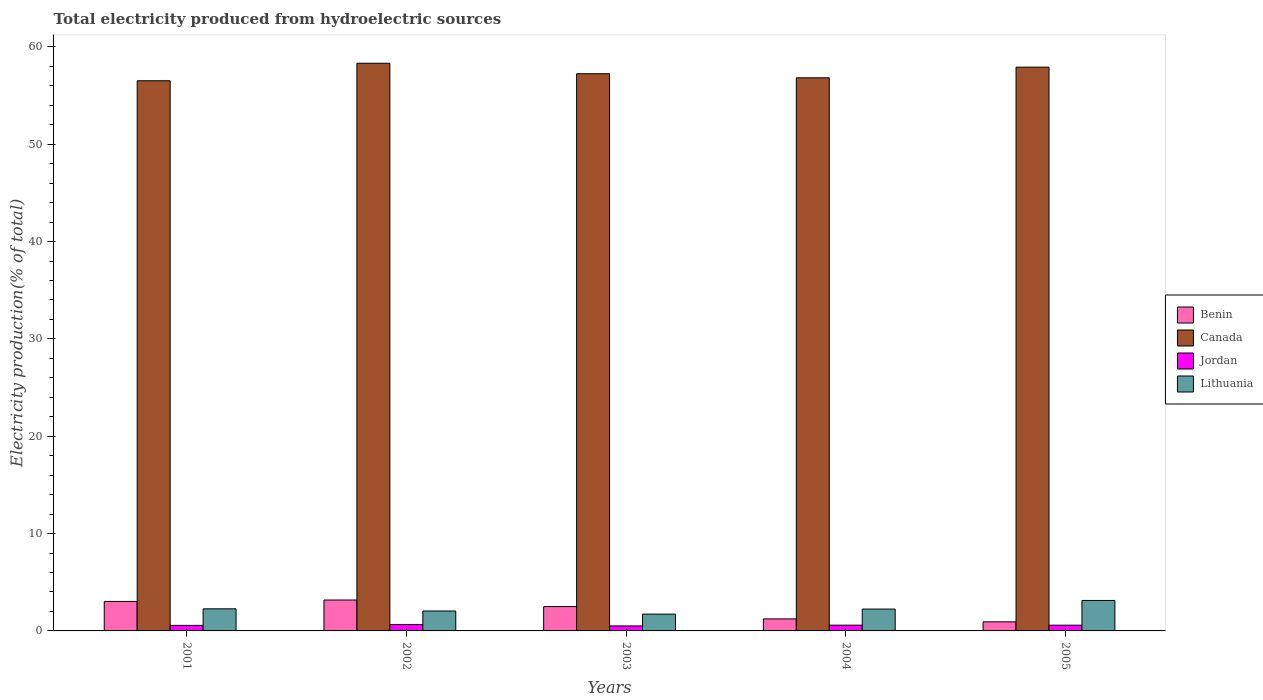How many different coloured bars are there?
Offer a terse response. 4. Are the number of bars per tick equal to the number of legend labels?
Offer a very short reply. Yes. Are the number of bars on each tick of the X-axis equal?
Offer a terse response. Yes. How many bars are there on the 4th tick from the left?
Give a very brief answer. 4. In how many cases, is the number of bars for a given year not equal to the number of legend labels?
Make the answer very short. 0. What is the total electricity produced in Benin in 2005?
Your response must be concise. 0.93. Across all years, what is the maximum total electricity produced in Lithuania?
Your answer should be compact. 3.13. Across all years, what is the minimum total electricity produced in Lithuania?
Offer a very short reply. 1.73. In which year was the total electricity produced in Lithuania maximum?
Offer a very short reply. 2005. What is the total total electricity produced in Jordan in the graph?
Your answer should be very brief. 2.92. What is the difference between the total electricity produced in Benin in 2001 and that in 2004?
Offer a very short reply. 1.8. What is the difference between the total electricity produced in Jordan in 2003 and the total electricity produced in Canada in 2001?
Offer a terse response. -56. What is the average total electricity produced in Jordan per year?
Your response must be concise. 0.58. In the year 2002, what is the difference between the total electricity produced in Benin and total electricity produced in Jordan?
Your response must be concise. 2.52. What is the ratio of the total electricity produced in Lithuania in 2002 to that in 2003?
Keep it short and to the point. 1.19. Is the difference between the total electricity produced in Benin in 2002 and 2005 greater than the difference between the total electricity produced in Jordan in 2002 and 2005?
Your response must be concise. Yes. What is the difference between the highest and the second highest total electricity produced in Canada?
Ensure brevity in your answer.  0.4. What is the difference between the highest and the lowest total electricity produced in Benin?
Your answer should be very brief. 2.24. In how many years, is the total electricity produced in Benin greater than the average total electricity produced in Benin taken over all years?
Your answer should be very brief. 3. Is it the case that in every year, the sum of the total electricity produced in Jordan and total electricity produced in Lithuania is greater than the sum of total electricity produced in Benin and total electricity produced in Canada?
Your answer should be compact. Yes. What does the 1st bar from the left in 2002 represents?
Your answer should be very brief. Benin. What does the 2nd bar from the right in 2004 represents?
Ensure brevity in your answer.  Jordan. Is it the case that in every year, the sum of the total electricity produced in Canada and total electricity produced in Jordan is greater than the total electricity produced in Benin?
Provide a succinct answer. Yes. How many bars are there?
Provide a short and direct response. 20. Are all the bars in the graph horizontal?
Provide a succinct answer. No. How many years are there in the graph?
Keep it short and to the point. 5. Are the values on the major ticks of Y-axis written in scientific E-notation?
Ensure brevity in your answer.  No. Where does the legend appear in the graph?
Provide a succinct answer. Center right. How many legend labels are there?
Your answer should be compact. 4. How are the legend labels stacked?
Offer a very short reply. Vertical. What is the title of the graph?
Ensure brevity in your answer.  Total electricity produced from hydroelectric sources. Does "Middle East & North Africa (developing only)" appear as one of the legend labels in the graph?
Your answer should be very brief. No. What is the Electricity production(% of total) in Benin in 2001?
Offer a very short reply. 3.03. What is the Electricity production(% of total) in Canada in 2001?
Provide a succinct answer. 56.52. What is the Electricity production(% of total) in Jordan in 2001?
Offer a terse response. 0.57. What is the Electricity production(% of total) of Lithuania in 2001?
Provide a short and direct response. 2.27. What is the Electricity production(% of total) in Benin in 2002?
Your response must be concise. 3.17. What is the Electricity production(% of total) in Canada in 2002?
Provide a short and direct response. 58.31. What is the Electricity production(% of total) in Jordan in 2002?
Keep it short and to the point. 0.65. What is the Electricity production(% of total) of Lithuania in 2002?
Give a very brief answer. 2.05. What is the Electricity production(% of total) of Benin in 2003?
Offer a very short reply. 2.5. What is the Electricity production(% of total) in Canada in 2003?
Keep it short and to the point. 57.24. What is the Electricity production(% of total) in Jordan in 2003?
Keep it short and to the point. 0.51. What is the Electricity production(% of total) of Lithuania in 2003?
Provide a short and direct response. 1.73. What is the Electricity production(% of total) of Benin in 2004?
Offer a very short reply. 1.23. What is the Electricity production(% of total) of Canada in 2004?
Your answer should be very brief. 56.82. What is the Electricity production(% of total) in Jordan in 2004?
Offer a terse response. 0.59. What is the Electricity production(% of total) in Lithuania in 2004?
Ensure brevity in your answer.  2.25. What is the Electricity production(% of total) in Benin in 2005?
Provide a short and direct response. 0.93. What is the Electricity production(% of total) of Canada in 2005?
Keep it short and to the point. 57.91. What is the Electricity production(% of total) in Jordan in 2005?
Provide a succinct answer. 0.59. What is the Electricity production(% of total) in Lithuania in 2005?
Provide a succinct answer. 3.13. Across all years, what is the maximum Electricity production(% of total) in Benin?
Provide a succinct answer. 3.17. Across all years, what is the maximum Electricity production(% of total) in Canada?
Your response must be concise. 58.31. Across all years, what is the maximum Electricity production(% of total) of Jordan?
Offer a terse response. 0.65. Across all years, what is the maximum Electricity production(% of total) of Lithuania?
Offer a very short reply. 3.13. Across all years, what is the minimum Electricity production(% of total) of Benin?
Make the answer very short. 0.93. Across all years, what is the minimum Electricity production(% of total) in Canada?
Give a very brief answer. 56.52. Across all years, what is the minimum Electricity production(% of total) in Jordan?
Ensure brevity in your answer.  0.51. Across all years, what is the minimum Electricity production(% of total) of Lithuania?
Your answer should be very brief. 1.73. What is the total Electricity production(% of total) in Benin in the graph?
Your response must be concise. 10.87. What is the total Electricity production(% of total) in Canada in the graph?
Provide a succinct answer. 286.8. What is the total Electricity production(% of total) of Jordan in the graph?
Your answer should be very brief. 2.92. What is the total Electricity production(% of total) of Lithuania in the graph?
Provide a succinct answer. 11.42. What is the difference between the Electricity production(% of total) of Benin in 2001 and that in 2002?
Keep it short and to the point. -0.14. What is the difference between the Electricity production(% of total) of Canada in 2001 and that in 2002?
Provide a succinct answer. -1.8. What is the difference between the Electricity production(% of total) of Jordan in 2001 and that in 2002?
Offer a terse response. -0.08. What is the difference between the Electricity production(% of total) in Lithuania in 2001 and that in 2002?
Make the answer very short. 0.22. What is the difference between the Electricity production(% of total) in Benin in 2001 and that in 2003?
Your response must be concise. 0.53. What is the difference between the Electricity production(% of total) of Canada in 2001 and that in 2003?
Your answer should be compact. -0.72. What is the difference between the Electricity production(% of total) of Jordan in 2001 and that in 2003?
Your response must be concise. 0.06. What is the difference between the Electricity production(% of total) in Lithuania in 2001 and that in 2003?
Your answer should be very brief. 0.54. What is the difference between the Electricity production(% of total) in Benin in 2001 and that in 2004?
Provide a succinct answer. 1.8. What is the difference between the Electricity production(% of total) in Canada in 2001 and that in 2004?
Ensure brevity in your answer.  -0.3. What is the difference between the Electricity production(% of total) in Jordan in 2001 and that in 2004?
Provide a succinct answer. -0.02. What is the difference between the Electricity production(% of total) in Lithuania in 2001 and that in 2004?
Ensure brevity in your answer.  0.02. What is the difference between the Electricity production(% of total) in Benin in 2001 and that in 2005?
Your answer should be compact. 2.1. What is the difference between the Electricity production(% of total) in Canada in 2001 and that in 2005?
Ensure brevity in your answer.  -1.4. What is the difference between the Electricity production(% of total) in Jordan in 2001 and that in 2005?
Offer a very short reply. -0.02. What is the difference between the Electricity production(% of total) of Lithuania in 2001 and that in 2005?
Ensure brevity in your answer.  -0.86. What is the difference between the Electricity production(% of total) of Benin in 2002 and that in 2003?
Make the answer very short. 0.67. What is the difference between the Electricity production(% of total) in Canada in 2002 and that in 2003?
Offer a very short reply. 1.07. What is the difference between the Electricity production(% of total) of Jordan in 2002 and that in 2003?
Your response must be concise. 0.14. What is the difference between the Electricity production(% of total) of Lithuania in 2002 and that in 2003?
Your answer should be very brief. 0.32. What is the difference between the Electricity production(% of total) in Benin in 2002 and that in 2004?
Your answer should be compact. 1.94. What is the difference between the Electricity production(% of total) of Canada in 2002 and that in 2004?
Your answer should be very brief. 1.49. What is the difference between the Electricity production(% of total) in Jordan in 2002 and that in 2004?
Your answer should be compact. 0.06. What is the difference between the Electricity production(% of total) in Lithuania in 2002 and that in 2004?
Offer a terse response. -0.2. What is the difference between the Electricity production(% of total) of Benin in 2002 and that in 2005?
Offer a very short reply. 2.24. What is the difference between the Electricity production(% of total) of Canada in 2002 and that in 2005?
Your answer should be very brief. 0.4. What is the difference between the Electricity production(% of total) of Jordan in 2002 and that in 2005?
Your response must be concise. 0.06. What is the difference between the Electricity production(% of total) in Lithuania in 2002 and that in 2005?
Offer a terse response. -1.08. What is the difference between the Electricity production(% of total) in Benin in 2003 and that in 2004?
Ensure brevity in your answer.  1.27. What is the difference between the Electricity production(% of total) in Canada in 2003 and that in 2004?
Offer a very short reply. 0.42. What is the difference between the Electricity production(% of total) of Jordan in 2003 and that in 2004?
Keep it short and to the point. -0.08. What is the difference between the Electricity production(% of total) of Lithuania in 2003 and that in 2004?
Ensure brevity in your answer.  -0.52. What is the difference between the Electricity production(% of total) in Benin in 2003 and that in 2005?
Give a very brief answer. 1.57. What is the difference between the Electricity production(% of total) in Canada in 2003 and that in 2005?
Your answer should be very brief. -0.68. What is the difference between the Electricity production(% of total) of Jordan in 2003 and that in 2005?
Ensure brevity in your answer.  -0.08. What is the difference between the Electricity production(% of total) of Lithuania in 2003 and that in 2005?
Your answer should be compact. -1.4. What is the difference between the Electricity production(% of total) of Canada in 2004 and that in 2005?
Your answer should be compact. -1.1. What is the difference between the Electricity production(% of total) of Jordan in 2004 and that in 2005?
Offer a very short reply. 0. What is the difference between the Electricity production(% of total) of Lithuania in 2004 and that in 2005?
Offer a very short reply. -0.88. What is the difference between the Electricity production(% of total) in Benin in 2001 and the Electricity production(% of total) in Canada in 2002?
Ensure brevity in your answer.  -55.28. What is the difference between the Electricity production(% of total) in Benin in 2001 and the Electricity production(% of total) in Jordan in 2002?
Your response must be concise. 2.38. What is the difference between the Electricity production(% of total) in Benin in 2001 and the Electricity production(% of total) in Lithuania in 2002?
Your answer should be very brief. 0.98. What is the difference between the Electricity production(% of total) of Canada in 2001 and the Electricity production(% of total) of Jordan in 2002?
Your answer should be very brief. 55.86. What is the difference between the Electricity production(% of total) of Canada in 2001 and the Electricity production(% of total) of Lithuania in 2002?
Give a very brief answer. 54.47. What is the difference between the Electricity production(% of total) in Jordan in 2001 and the Electricity production(% of total) in Lithuania in 2002?
Provide a succinct answer. -1.48. What is the difference between the Electricity production(% of total) in Benin in 2001 and the Electricity production(% of total) in Canada in 2003?
Provide a short and direct response. -54.21. What is the difference between the Electricity production(% of total) in Benin in 2001 and the Electricity production(% of total) in Jordan in 2003?
Keep it short and to the point. 2.52. What is the difference between the Electricity production(% of total) of Benin in 2001 and the Electricity production(% of total) of Lithuania in 2003?
Ensure brevity in your answer.  1.3. What is the difference between the Electricity production(% of total) in Canada in 2001 and the Electricity production(% of total) in Jordan in 2003?
Offer a very short reply. 56. What is the difference between the Electricity production(% of total) in Canada in 2001 and the Electricity production(% of total) in Lithuania in 2003?
Your answer should be very brief. 54.79. What is the difference between the Electricity production(% of total) in Jordan in 2001 and the Electricity production(% of total) in Lithuania in 2003?
Provide a short and direct response. -1.16. What is the difference between the Electricity production(% of total) in Benin in 2001 and the Electricity production(% of total) in Canada in 2004?
Your answer should be very brief. -53.79. What is the difference between the Electricity production(% of total) of Benin in 2001 and the Electricity production(% of total) of Jordan in 2004?
Your answer should be very brief. 2.44. What is the difference between the Electricity production(% of total) in Benin in 2001 and the Electricity production(% of total) in Lithuania in 2004?
Offer a terse response. 0.79. What is the difference between the Electricity production(% of total) of Canada in 2001 and the Electricity production(% of total) of Jordan in 2004?
Keep it short and to the point. 55.92. What is the difference between the Electricity production(% of total) of Canada in 2001 and the Electricity production(% of total) of Lithuania in 2004?
Your answer should be compact. 54.27. What is the difference between the Electricity production(% of total) of Jordan in 2001 and the Electricity production(% of total) of Lithuania in 2004?
Provide a short and direct response. -1.68. What is the difference between the Electricity production(% of total) of Benin in 2001 and the Electricity production(% of total) of Canada in 2005?
Offer a terse response. -54.88. What is the difference between the Electricity production(% of total) of Benin in 2001 and the Electricity production(% of total) of Jordan in 2005?
Give a very brief answer. 2.44. What is the difference between the Electricity production(% of total) in Benin in 2001 and the Electricity production(% of total) in Lithuania in 2005?
Your response must be concise. -0.1. What is the difference between the Electricity production(% of total) in Canada in 2001 and the Electricity production(% of total) in Jordan in 2005?
Keep it short and to the point. 55.93. What is the difference between the Electricity production(% of total) of Canada in 2001 and the Electricity production(% of total) of Lithuania in 2005?
Offer a terse response. 53.39. What is the difference between the Electricity production(% of total) in Jordan in 2001 and the Electricity production(% of total) in Lithuania in 2005?
Your answer should be compact. -2.56. What is the difference between the Electricity production(% of total) in Benin in 2002 and the Electricity production(% of total) in Canada in 2003?
Make the answer very short. -54.06. What is the difference between the Electricity production(% of total) in Benin in 2002 and the Electricity production(% of total) in Jordan in 2003?
Your answer should be compact. 2.66. What is the difference between the Electricity production(% of total) in Benin in 2002 and the Electricity production(% of total) in Lithuania in 2003?
Make the answer very short. 1.45. What is the difference between the Electricity production(% of total) in Canada in 2002 and the Electricity production(% of total) in Jordan in 2003?
Your response must be concise. 57.8. What is the difference between the Electricity production(% of total) in Canada in 2002 and the Electricity production(% of total) in Lithuania in 2003?
Ensure brevity in your answer.  56.59. What is the difference between the Electricity production(% of total) in Jordan in 2002 and the Electricity production(% of total) in Lithuania in 2003?
Provide a succinct answer. -1.07. What is the difference between the Electricity production(% of total) in Benin in 2002 and the Electricity production(% of total) in Canada in 2004?
Keep it short and to the point. -53.64. What is the difference between the Electricity production(% of total) in Benin in 2002 and the Electricity production(% of total) in Jordan in 2004?
Provide a short and direct response. 2.58. What is the difference between the Electricity production(% of total) in Benin in 2002 and the Electricity production(% of total) in Lithuania in 2004?
Make the answer very short. 0.93. What is the difference between the Electricity production(% of total) in Canada in 2002 and the Electricity production(% of total) in Jordan in 2004?
Give a very brief answer. 57.72. What is the difference between the Electricity production(% of total) of Canada in 2002 and the Electricity production(% of total) of Lithuania in 2004?
Offer a terse response. 56.07. What is the difference between the Electricity production(% of total) of Jordan in 2002 and the Electricity production(% of total) of Lithuania in 2004?
Keep it short and to the point. -1.59. What is the difference between the Electricity production(% of total) in Benin in 2002 and the Electricity production(% of total) in Canada in 2005?
Your answer should be compact. -54.74. What is the difference between the Electricity production(% of total) of Benin in 2002 and the Electricity production(% of total) of Jordan in 2005?
Provide a short and direct response. 2.58. What is the difference between the Electricity production(% of total) of Benin in 2002 and the Electricity production(% of total) of Lithuania in 2005?
Offer a terse response. 0.05. What is the difference between the Electricity production(% of total) in Canada in 2002 and the Electricity production(% of total) in Jordan in 2005?
Your answer should be compact. 57.72. What is the difference between the Electricity production(% of total) of Canada in 2002 and the Electricity production(% of total) of Lithuania in 2005?
Provide a short and direct response. 55.18. What is the difference between the Electricity production(% of total) in Jordan in 2002 and the Electricity production(% of total) in Lithuania in 2005?
Provide a succinct answer. -2.48. What is the difference between the Electricity production(% of total) of Benin in 2003 and the Electricity production(% of total) of Canada in 2004?
Provide a succinct answer. -54.32. What is the difference between the Electricity production(% of total) in Benin in 2003 and the Electricity production(% of total) in Jordan in 2004?
Keep it short and to the point. 1.91. What is the difference between the Electricity production(% of total) in Benin in 2003 and the Electricity production(% of total) in Lithuania in 2004?
Give a very brief answer. 0.25. What is the difference between the Electricity production(% of total) in Canada in 2003 and the Electricity production(% of total) in Jordan in 2004?
Ensure brevity in your answer.  56.65. What is the difference between the Electricity production(% of total) in Canada in 2003 and the Electricity production(% of total) in Lithuania in 2004?
Your response must be concise. 54.99. What is the difference between the Electricity production(% of total) in Jordan in 2003 and the Electricity production(% of total) in Lithuania in 2004?
Offer a very short reply. -1.73. What is the difference between the Electricity production(% of total) in Benin in 2003 and the Electricity production(% of total) in Canada in 2005?
Your answer should be very brief. -55.41. What is the difference between the Electricity production(% of total) of Benin in 2003 and the Electricity production(% of total) of Jordan in 2005?
Make the answer very short. 1.91. What is the difference between the Electricity production(% of total) in Benin in 2003 and the Electricity production(% of total) in Lithuania in 2005?
Your response must be concise. -0.63. What is the difference between the Electricity production(% of total) of Canada in 2003 and the Electricity production(% of total) of Jordan in 2005?
Provide a succinct answer. 56.65. What is the difference between the Electricity production(% of total) of Canada in 2003 and the Electricity production(% of total) of Lithuania in 2005?
Give a very brief answer. 54.11. What is the difference between the Electricity production(% of total) in Jordan in 2003 and the Electricity production(% of total) in Lithuania in 2005?
Your answer should be compact. -2.62. What is the difference between the Electricity production(% of total) in Benin in 2004 and the Electricity production(% of total) in Canada in 2005?
Offer a very short reply. -56.68. What is the difference between the Electricity production(% of total) of Benin in 2004 and the Electricity production(% of total) of Jordan in 2005?
Your response must be concise. 0.64. What is the difference between the Electricity production(% of total) of Benin in 2004 and the Electricity production(% of total) of Lithuania in 2005?
Provide a succinct answer. -1.89. What is the difference between the Electricity production(% of total) of Canada in 2004 and the Electricity production(% of total) of Jordan in 2005?
Make the answer very short. 56.23. What is the difference between the Electricity production(% of total) of Canada in 2004 and the Electricity production(% of total) of Lithuania in 2005?
Offer a terse response. 53.69. What is the difference between the Electricity production(% of total) in Jordan in 2004 and the Electricity production(% of total) in Lithuania in 2005?
Offer a very short reply. -2.54. What is the average Electricity production(% of total) of Benin per year?
Your response must be concise. 2.17. What is the average Electricity production(% of total) of Canada per year?
Your answer should be compact. 57.36. What is the average Electricity production(% of total) in Jordan per year?
Offer a very short reply. 0.58. What is the average Electricity production(% of total) in Lithuania per year?
Your answer should be compact. 2.28. In the year 2001, what is the difference between the Electricity production(% of total) of Benin and Electricity production(% of total) of Canada?
Offer a terse response. -53.49. In the year 2001, what is the difference between the Electricity production(% of total) of Benin and Electricity production(% of total) of Jordan?
Keep it short and to the point. 2.46. In the year 2001, what is the difference between the Electricity production(% of total) in Benin and Electricity production(% of total) in Lithuania?
Your response must be concise. 0.76. In the year 2001, what is the difference between the Electricity production(% of total) in Canada and Electricity production(% of total) in Jordan?
Your answer should be compact. 55.95. In the year 2001, what is the difference between the Electricity production(% of total) of Canada and Electricity production(% of total) of Lithuania?
Your answer should be compact. 54.25. In the year 2001, what is the difference between the Electricity production(% of total) of Jordan and Electricity production(% of total) of Lithuania?
Offer a very short reply. -1.7. In the year 2002, what is the difference between the Electricity production(% of total) in Benin and Electricity production(% of total) in Canada?
Keep it short and to the point. -55.14. In the year 2002, what is the difference between the Electricity production(% of total) in Benin and Electricity production(% of total) in Jordan?
Your answer should be compact. 2.52. In the year 2002, what is the difference between the Electricity production(% of total) of Benin and Electricity production(% of total) of Lithuania?
Your response must be concise. 1.13. In the year 2002, what is the difference between the Electricity production(% of total) of Canada and Electricity production(% of total) of Jordan?
Offer a very short reply. 57.66. In the year 2002, what is the difference between the Electricity production(% of total) of Canada and Electricity production(% of total) of Lithuania?
Offer a very short reply. 56.27. In the year 2002, what is the difference between the Electricity production(% of total) of Jordan and Electricity production(% of total) of Lithuania?
Make the answer very short. -1.4. In the year 2003, what is the difference between the Electricity production(% of total) of Benin and Electricity production(% of total) of Canada?
Give a very brief answer. -54.74. In the year 2003, what is the difference between the Electricity production(% of total) of Benin and Electricity production(% of total) of Jordan?
Your response must be concise. 1.99. In the year 2003, what is the difference between the Electricity production(% of total) in Benin and Electricity production(% of total) in Lithuania?
Ensure brevity in your answer.  0.77. In the year 2003, what is the difference between the Electricity production(% of total) in Canada and Electricity production(% of total) in Jordan?
Provide a short and direct response. 56.73. In the year 2003, what is the difference between the Electricity production(% of total) of Canada and Electricity production(% of total) of Lithuania?
Offer a terse response. 55.51. In the year 2003, what is the difference between the Electricity production(% of total) of Jordan and Electricity production(% of total) of Lithuania?
Make the answer very short. -1.21. In the year 2004, what is the difference between the Electricity production(% of total) in Benin and Electricity production(% of total) in Canada?
Provide a short and direct response. -55.58. In the year 2004, what is the difference between the Electricity production(% of total) of Benin and Electricity production(% of total) of Jordan?
Provide a succinct answer. 0.64. In the year 2004, what is the difference between the Electricity production(% of total) of Benin and Electricity production(% of total) of Lithuania?
Offer a terse response. -1.01. In the year 2004, what is the difference between the Electricity production(% of total) in Canada and Electricity production(% of total) in Jordan?
Provide a succinct answer. 56.23. In the year 2004, what is the difference between the Electricity production(% of total) of Canada and Electricity production(% of total) of Lithuania?
Provide a succinct answer. 54.57. In the year 2004, what is the difference between the Electricity production(% of total) in Jordan and Electricity production(% of total) in Lithuania?
Provide a succinct answer. -1.65. In the year 2005, what is the difference between the Electricity production(% of total) in Benin and Electricity production(% of total) in Canada?
Make the answer very short. -56.98. In the year 2005, what is the difference between the Electricity production(% of total) in Benin and Electricity production(% of total) in Jordan?
Give a very brief answer. 0.34. In the year 2005, what is the difference between the Electricity production(% of total) of Benin and Electricity production(% of total) of Lithuania?
Your answer should be compact. -2.19. In the year 2005, what is the difference between the Electricity production(% of total) of Canada and Electricity production(% of total) of Jordan?
Provide a short and direct response. 57.32. In the year 2005, what is the difference between the Electricity production(% of total) in Canada and Electricity production(% of total) in Lithuania?
Give a very brief answer. 54.79. In the year 2005, what is the difference between the Electricity production(% of total) of Jordan and Electricity production(% of total) of Lithuania?
Provide a short and direct response. -2.54. What is the ratio of the Electricity production(% of total) of Benin in 2001 to that in 2002?
Provide a succinct answer. 0.95. What is the ratio of the Electricity production(% of total) of Canada in 2001 to that in 2002?
Your answer should be very brief. 0.97. What is the ratio of the Electricity production(% of total) of Jordan in 2001 to that in 2002?
Make the answer very short. 0.87. What is the ratio of the Electricity production(% of total) in Lithuania in 2001 to that in 2002?
Keep it short and to the point. 1.11. What is the ratio of the Electricity production(% of total) in Benin in 2001 to that in 2003?
Offer a very short reply. 1.21. What is the ratio of the Electricity production(% of total) in Canada in 2001 to that in 2003?
Your answer should be compact. 0.99. What is the ratio of the Electricity production(% of total) of Jordan in 2001 to that in 2003?
Provide a short and direct response. 1.11. What is the ratio of the Electricity production(% of total) in Lithuania in 2001 to that in 2003?
Offer a very short reply. 1.31. What is the ratio of the Electricity production(% of total) of Benin in 2001 to that in 2004?
Your answer should be compact. 2.45. What is the ratio of the Electricity production(% of total) of Canada in 2001 to that in 2004?
Provide a short and direct response. 0.99. What is the ratio of the Electricity production(% of total) in Jordan in 2001 to that in 2004?
Ensure brevity in your answer.  0.96. What is the ratio of the Electricity production(% of total) in Benin in 2001 to that in 2005?
Offer a terse response. 3.24. What is the ratio of the Electricity production(% of total) in Canada in 2001 to that in 2005?
Make the answer very short. 0.98. What is the ratio of the Electricity production(% of total) of Jordan in 2001 to that in 2005?
Your answer should be very brief. 0.96. What is the ratio of the Electricity production(% of total) in Lithuania in 2001 to that in 2005?
Ensure brevity in your answer.  0.73. What is the ratio of the Electricity production(% of total) of Benin in 2002 to that in 2003?
Offer a very short reply. 1.27. What is the ratio of the Electricity production(% of total) in Canada in 2002 to that in 2003?
Your answer should be very brief. 1.02. What is the ratio of the Electricity production(% of total) in Jordan in 2002 to that in 2003?
Give a very brief answer. 1.27. What is the ratio of the Electricity production(% of total) of Lithuania in 2002 to that in 2003?
Provide a succinct answer. 1.19. What is the ratio of the Electricity production(% of total) in Benin in 2002 to that in 2004?
Give a very brief answer. 2.57. What is the ratio of the Electricity production(% of total) in Canada in 2002 to that in 2004?
Offer a terse response. 1.03. What is the ratio of the Electricity production(% of total) of Jordan in 2002 to that in 2004?
Make the answer very short. 1.1. What is the ratio of the Electricity production(% of total) in Lithuania in 2002 to that in 2004?
Make the answer very short. 0.91. What is the ratio of the Electricity production(% of total) of Benin in 2002 to that in 2005?
Provide a short and direct response. 3.4. What is the ratio of the Electricity production(% of total) in Canada in 2002 to that in 2005?
Offer a terse response. 1.01. What is the ratio of the Electricity production(% of total) of Jordan in 2002 to that in 2005?
Offer a very short reply. 1.1. What is the ratio of the Electricity production(% of total) of Lithuania in 2002 to that in 2005?
Keep it short and to the point. 0.65. What is the ratio of the Electricity production(% of total) in Benin in 2003 to that in 2004?
Provide a short and direct response. 2.02. What is the ratio of the Electricity production(% of total) in Canada in 2003 to that in 2004?
Offer a terse response. 1.01. What is the ratio of the Electricity production(% of total) of Jordan in 2003 to that in 2004?
Keep it short and to the point. 0.87. What is the ratio of the Electricity production(% of total) in Lithuania in 2003 to that in 2004?
Make the answer very short. 0.77. What is the ratio of the Electricity production(% of total) in Benin in 2003 to that in 2005?
Make the answer very short. 2.67. What is the ratio of the Electricity production(% of total) of Canada in 2003 to that in 2005?
Offer a terse response. 0.99. What is the ratio of the Electricity production(% of total) of Jordan in 2003 to that in 2005?
Provide a succinct answer. 0.87. What is the ratio of the Electricity production(% of total) of Lithuania in 2003 to that in 2005?
Your answer should be very brief. 0.55. What is the ratio of the Electricity production(% of total) of Benin in 2004 to that in 2005?
Make the answer very short. 1.32. What is the ratio of the Electricity production(% of total) in Canada in 2004 to that in 2005?
Provide a succinct answer. 0.98. What is the ratio of the Electricity production(% of total) of Jordan in 2004 to that in 2005?
Offer a terse response. 1. What is the ratio of the Electricity production(% of total) in Lithuania in 2004 to that in 2005?
Your response must be concise. 0.72. What is the difference between the highest and the second highest Electricity production(% of total) of Benin?
Make the answer very short. 0.14. What is the difference between the highest and the second highest Electricity production(% of total) in Canada?
Offer a terse response. 0.4. What is the difference between the highest and the second highest Electricity production(% of total) in Jordan?
Offer a terse response. 0.06. What is the difference between the highest and the second highest Electricity production(% of total) in Lithuania?
Provide a succinct answer. 0.86. What is the difference between the highest and the lowest Electricity production(% of total) of Benin?
Provide a short and direct response. 2.24. What is the difference between the highest and the lowest Electricity production(% of total) in Canada?
Your answer should be compact. 1.8. What is the difference between the highest and the lowest Electricity production(% of total) in Jordan?
Provide a short and direct response. 0.14. What is the difference between the highest and the lowest Electricity production(% of total) in Lithuania?
Provide a succinct answer. 1.4. 